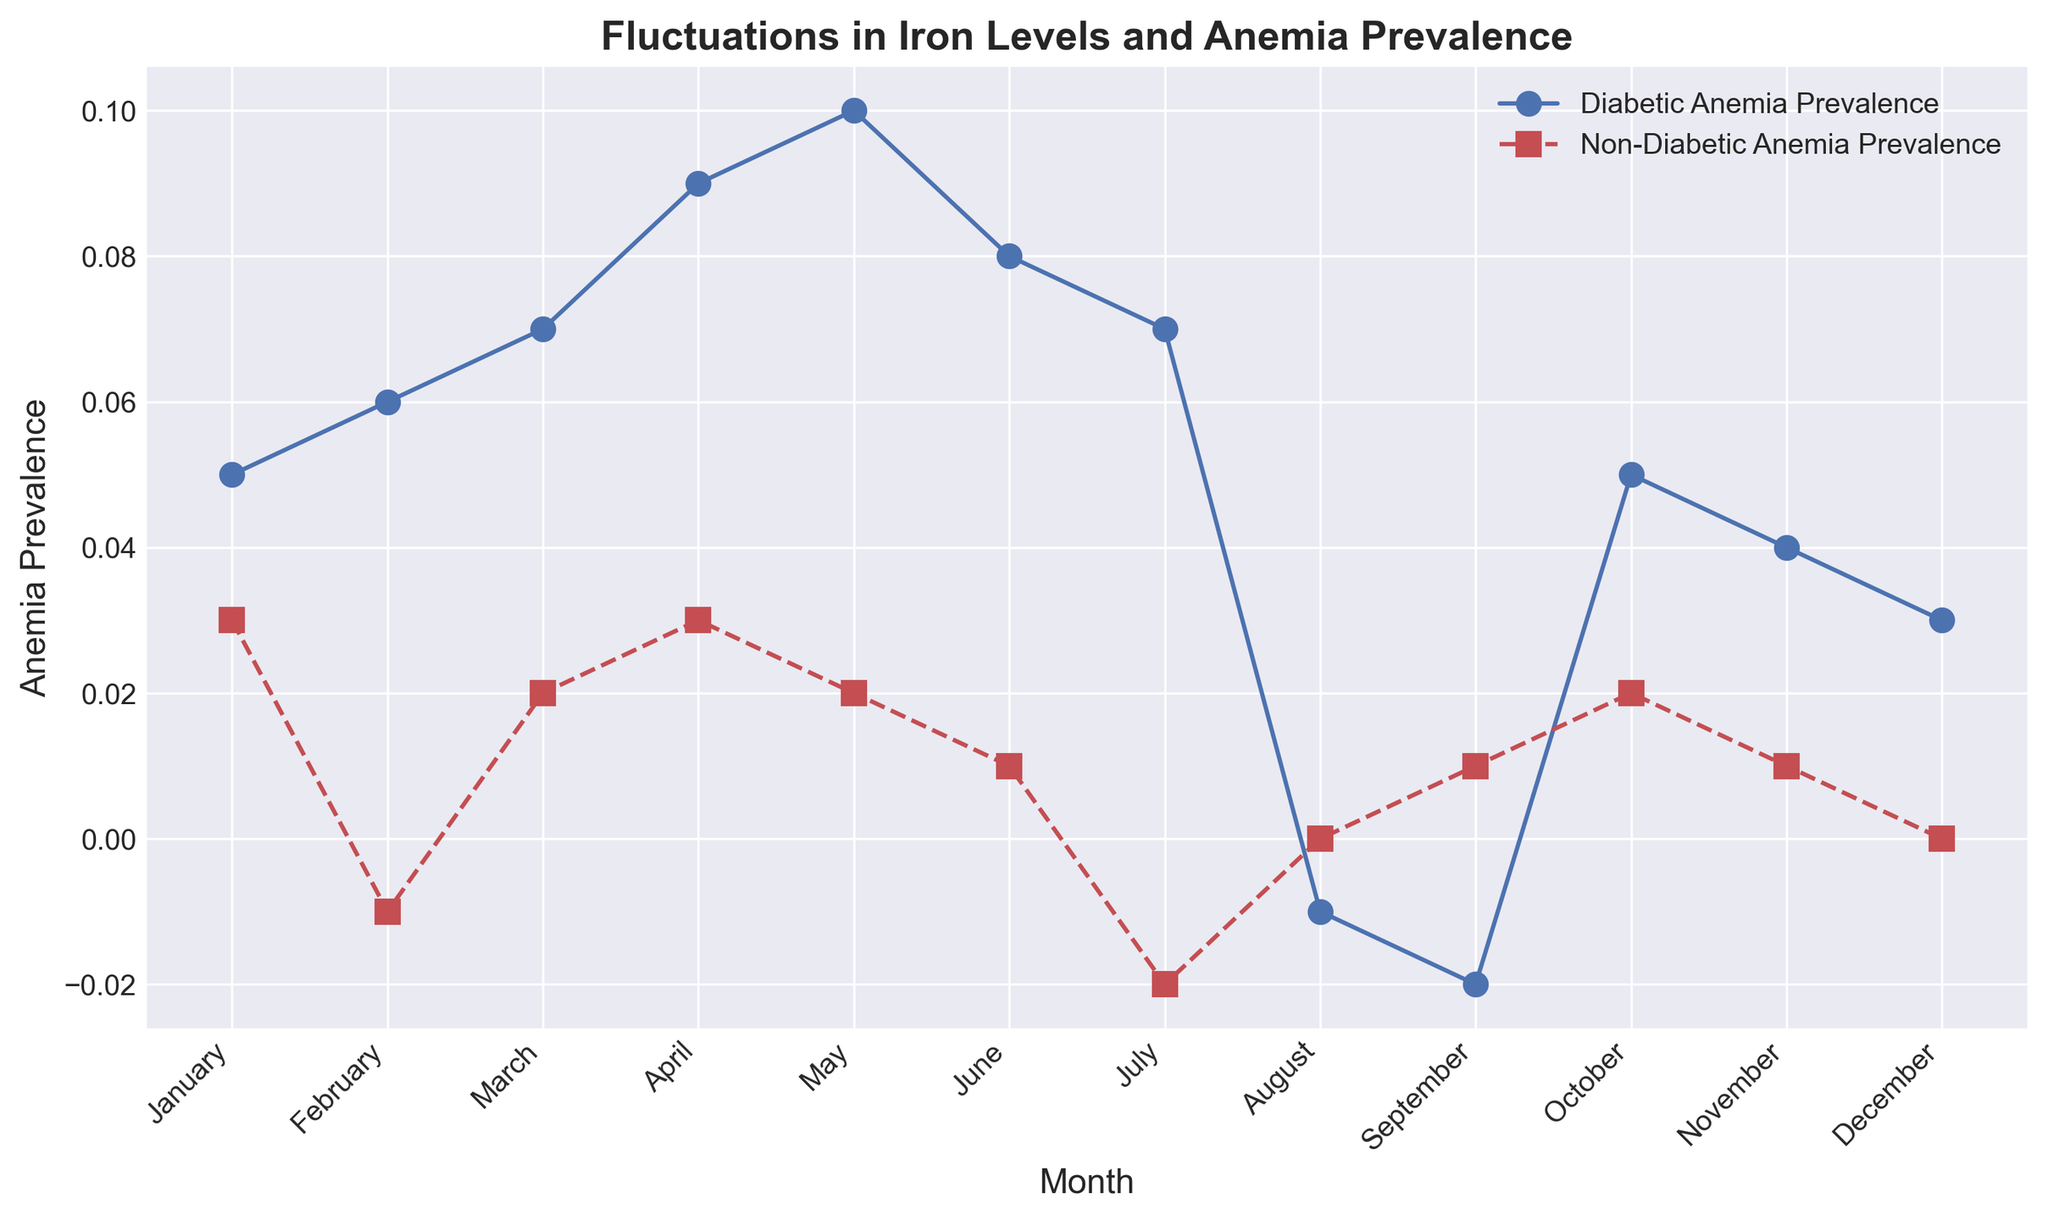What's the average monthly Diabetic Anemia Prevalence during the first half of the year? To calculate the average, sum the values for January to June (0.05 + 0.06 + 0.07 + 0.09 + 0.1 + 0.08) and divide by 6. This results in 0.45/6.
Answer: 0.075 In which month did Non-Diabetic Anemia Prevalence go negative? To find the negative values, look for months where the Non-Diabetic Anemia Prevalence line (red) dips below 0. It went negative in February (-0.01) and July (-0.02).
Answer: February, July Compare the peak Prevalence of Diabetic Anemia and Non-Diabetic Anemia. Which one is higher and by how much? Identify the highest points for both groups on the chart. Diabetic peaks at 0.10 in May, Non-Diabetic peaks at 0.03 in January and April. The difference is 0.10 - 0.03.
Answer: Diabetic, 0.07 Which month saw the largest drop in Diabetic Anemia Prevalence from the previous month? Compare the differences month-to-month for Diabetic Anemia. The largest drop is from May to June (0.10 to 0.08), a difference of -0.02.
Answer: June What's the range of Non-Diabetic Anemia Prevalence values throughout the year? The range is calculated by subtracting the minimum value from the maximum value for Non-Diabetic Anemia Prevalence. The maximum is 0.03, and the minimum is -0.02. Range = 0.03 - (-0.02) = 0.05.
Answer: 0.05 How does Diabetic Anemia Prevalence in November compare to that in July? Compare the values directly from the figure. In November, the prevalence is 0.04, and in July, it is 0.07. July is higher than November by 0.03.
Answer: July is higher by 0.03 Between which two consecutive months did Non-Diabetic Anemia Prevalence increase the most? Look for the largest positive change between two consecutive months. The largest increase is from July to August (-0.02 to 0.00), a change of 0.02.
Answer: July to August What's the sum of Diabetic Anemia Prevalence for October, November, and December? Sum the values for these months: 0.05 (Oct) + 0.04 (Nov) + 0.03 (Dec) = 0.12.
Answer: 0.12 Which month experienced the lowest Diabetic Anemia Prevalence, and what was the value? The lowest point on the Diabetic Anemia line (blue) is in August, with a value of -0.01.
Answer: August, -0.01 During which month is the difference between Diabetic and Non-Diabetic Anemia Prevalence the greatest? Determine the differences for each month and identify the maximum. The greatest difference is in April (0.09 - 0.03 = 0.06).
Answer: April, 0.06 